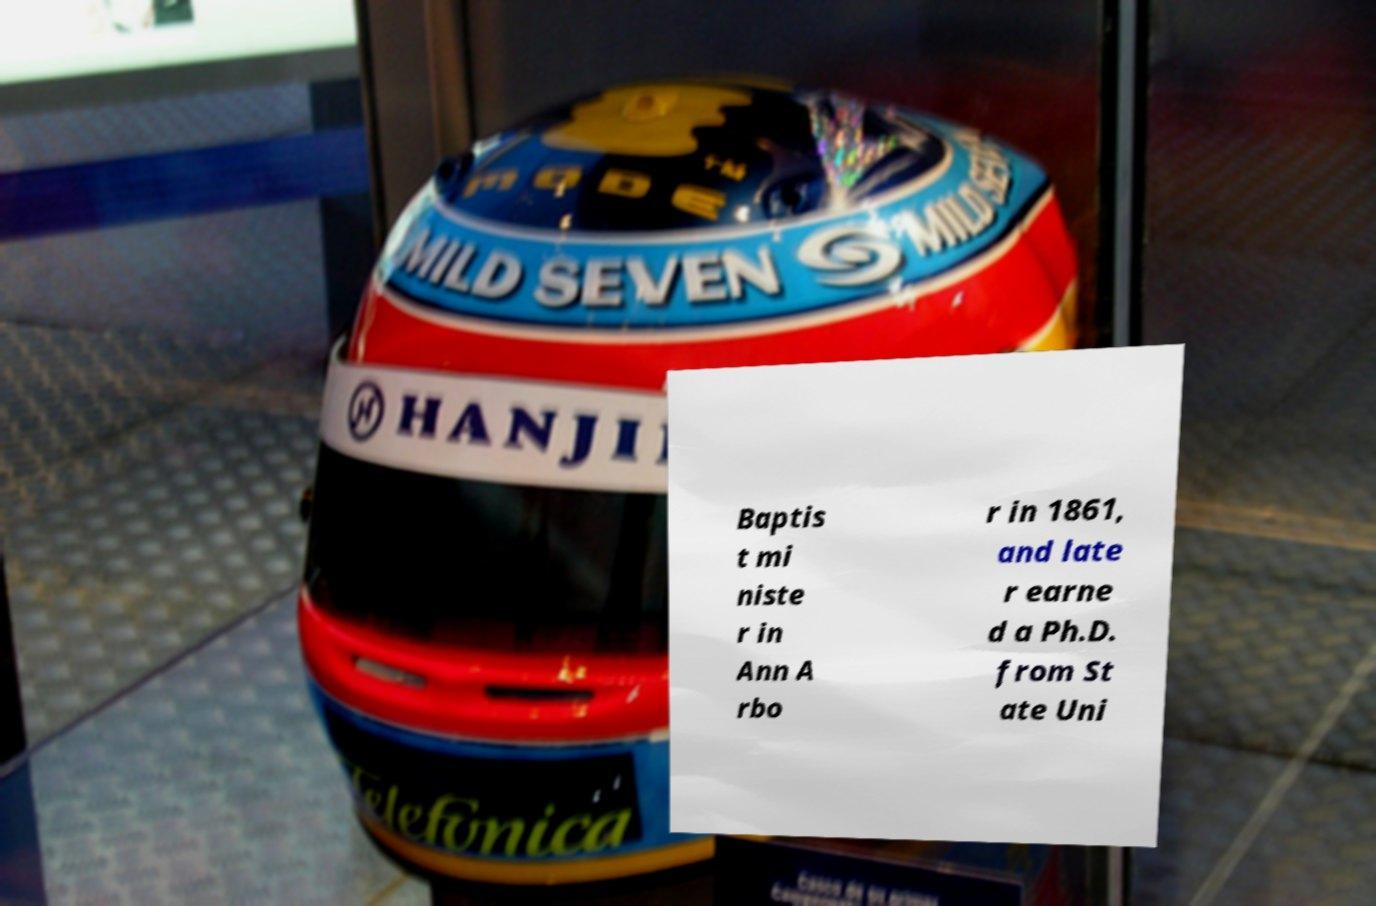For documentation purposes, I need the text within this image transcribed. Could you provide that? Baptis t mi niste r in Ann A rbo r in 1861, and late r earne d a Ph.D. from St ate Uni 